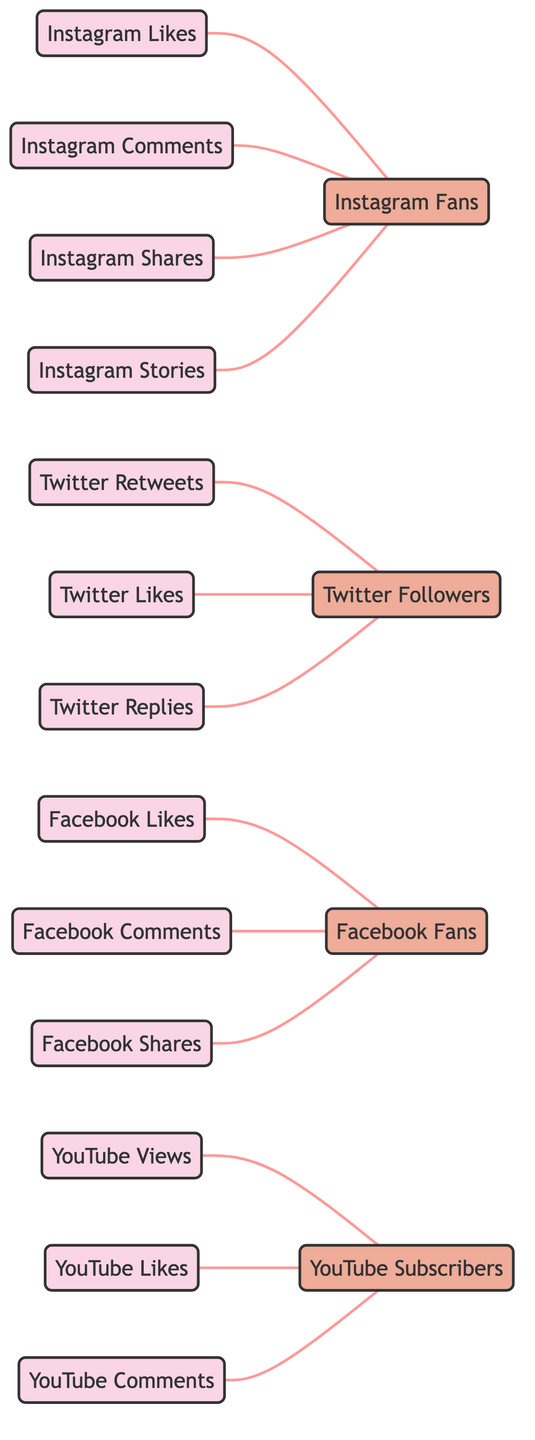What's the total number of nodes in the diagram? The diagram includes nodes that represent various engagement metrics and follower counts, counting both types: metrics and followers. There are 17 nodes in total: 13 metrics and 4 followers.
Answer: 17 How many edges connect to the Instagram Fans node? The Instagram Fans node is connected through edges from Instagram Likes, Instagram Comments, Instagram Shares, and Instagram Stories. Counting these edges, we find there are 4 connections to this node.
Answer: 4 Which social media platform has the highest total metrics illustrated in the diagram? Counting the connections (edges) for each platform: Instagram has 4, Twitter has 3, Facebook has 3, and YouTube has 3. Therefore, Instagram has the highest number of metrics illustrated.
Answer: Instagram What type of node is connected to Twitter Likes? Twitter Likes connects to the Twitter Followers node. The Twitter Followers is categorized as a follower type node in the diagram.
Answer: follower Is there a direct connection between YouTube Views and Instagram Likes? Examining the edges in the diagram, it is clear that YouTube Views and Instagram Likes are not directly connected. Each connects to their own respective follower nodes only.
Answer: No Which engagement metric has the most edges connecting to it? Each engagement metric is examined based on the incoming connections. All engagement metrics have exactly 4 edges connecting to them for Instagram, but Twitter metrics have 3 edges connecting to them. Thus, Instagram engagement metrics have the most edges.
Answer: Instagram Likes Are Facebook Shares and Instagram Shares connected? By reviewing the edges in the diagram, Facebook Shares connects exclusively to Facebook Fans, whereas Instagram Shares connects to Instagram Fans. There are no direct connections between Facebook Shares and Instagram Shares.
Answer: No How many types of nodes are present in the diagram? The diagram consists of two types of nodes: metrics and followers. The metrics represent engagement measures while the followers represent counts of people on each platform.
Answer: 2 What is the relationship between YouTube Likes and YouTube Subscribers? YouTube Likes connects to the YouTube Subscribers node, indicating that an increase in YouTube Likes may reflect an increase in subscribers. This connection shows a direct relationship between these two nodes.
Answer: connected 